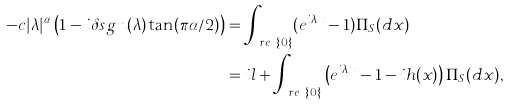Convert formula to latex. <formula><loc_0><loc_0><loc_500><loc_500>- c | \lambda | ^ { \alpha } \left ( 1 - i \delta s g n ( \lambda ) \tan ( \pi \alpha / 2 ) \right ) & = \int _ { \ r e \ \{ 0 \} } ( e ^ { i \lambda x } - 1 ) \Pi _ { S } ( d x ) \\ & = i l + \int _ { \ r e \ \{ 0 \} } \left ( e ^ { i \lambda x } - 1 - i h ( x ) \right ) \Pi _ { S } ( d x ) ,</formula> 